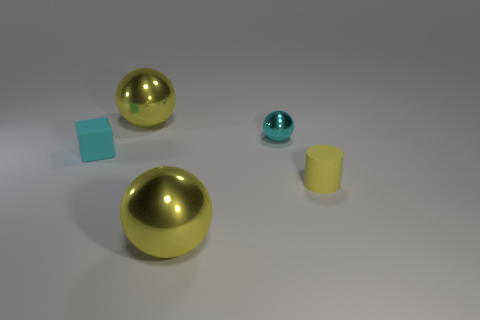Subtract all green cylinders. Subtract all red cubes. How many cylinders are left? 1 Add 3 yellow matte things. How many objects exist? 8 Subtract all spheres. How many objects are left? 2 Subtract all large metallic objects. Subtract all blocks. How many objects are left? 2 Add 4 shiny things. How many shiny things are left? 7 Add 5 small cyan matte objects. How many small cyan matte objects exist? 6 Subtract 0 blue cylinders. How many objects are left? 5 